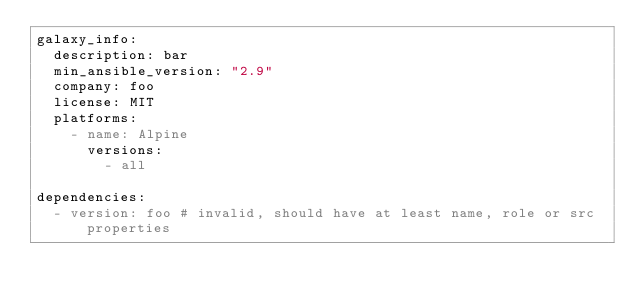<code> <loc_0><loc_0><loc_500><loc_500><_YAML_>galaxy_info:
  description: bar
  min_ansible_version: "2.9"
  company: foo
  license: MIT
  platforms:
    - name: Alpine
      versions:
        - all

dependencies:
  - version: foo # invalid, should have at least name, role or src properties
</code> 